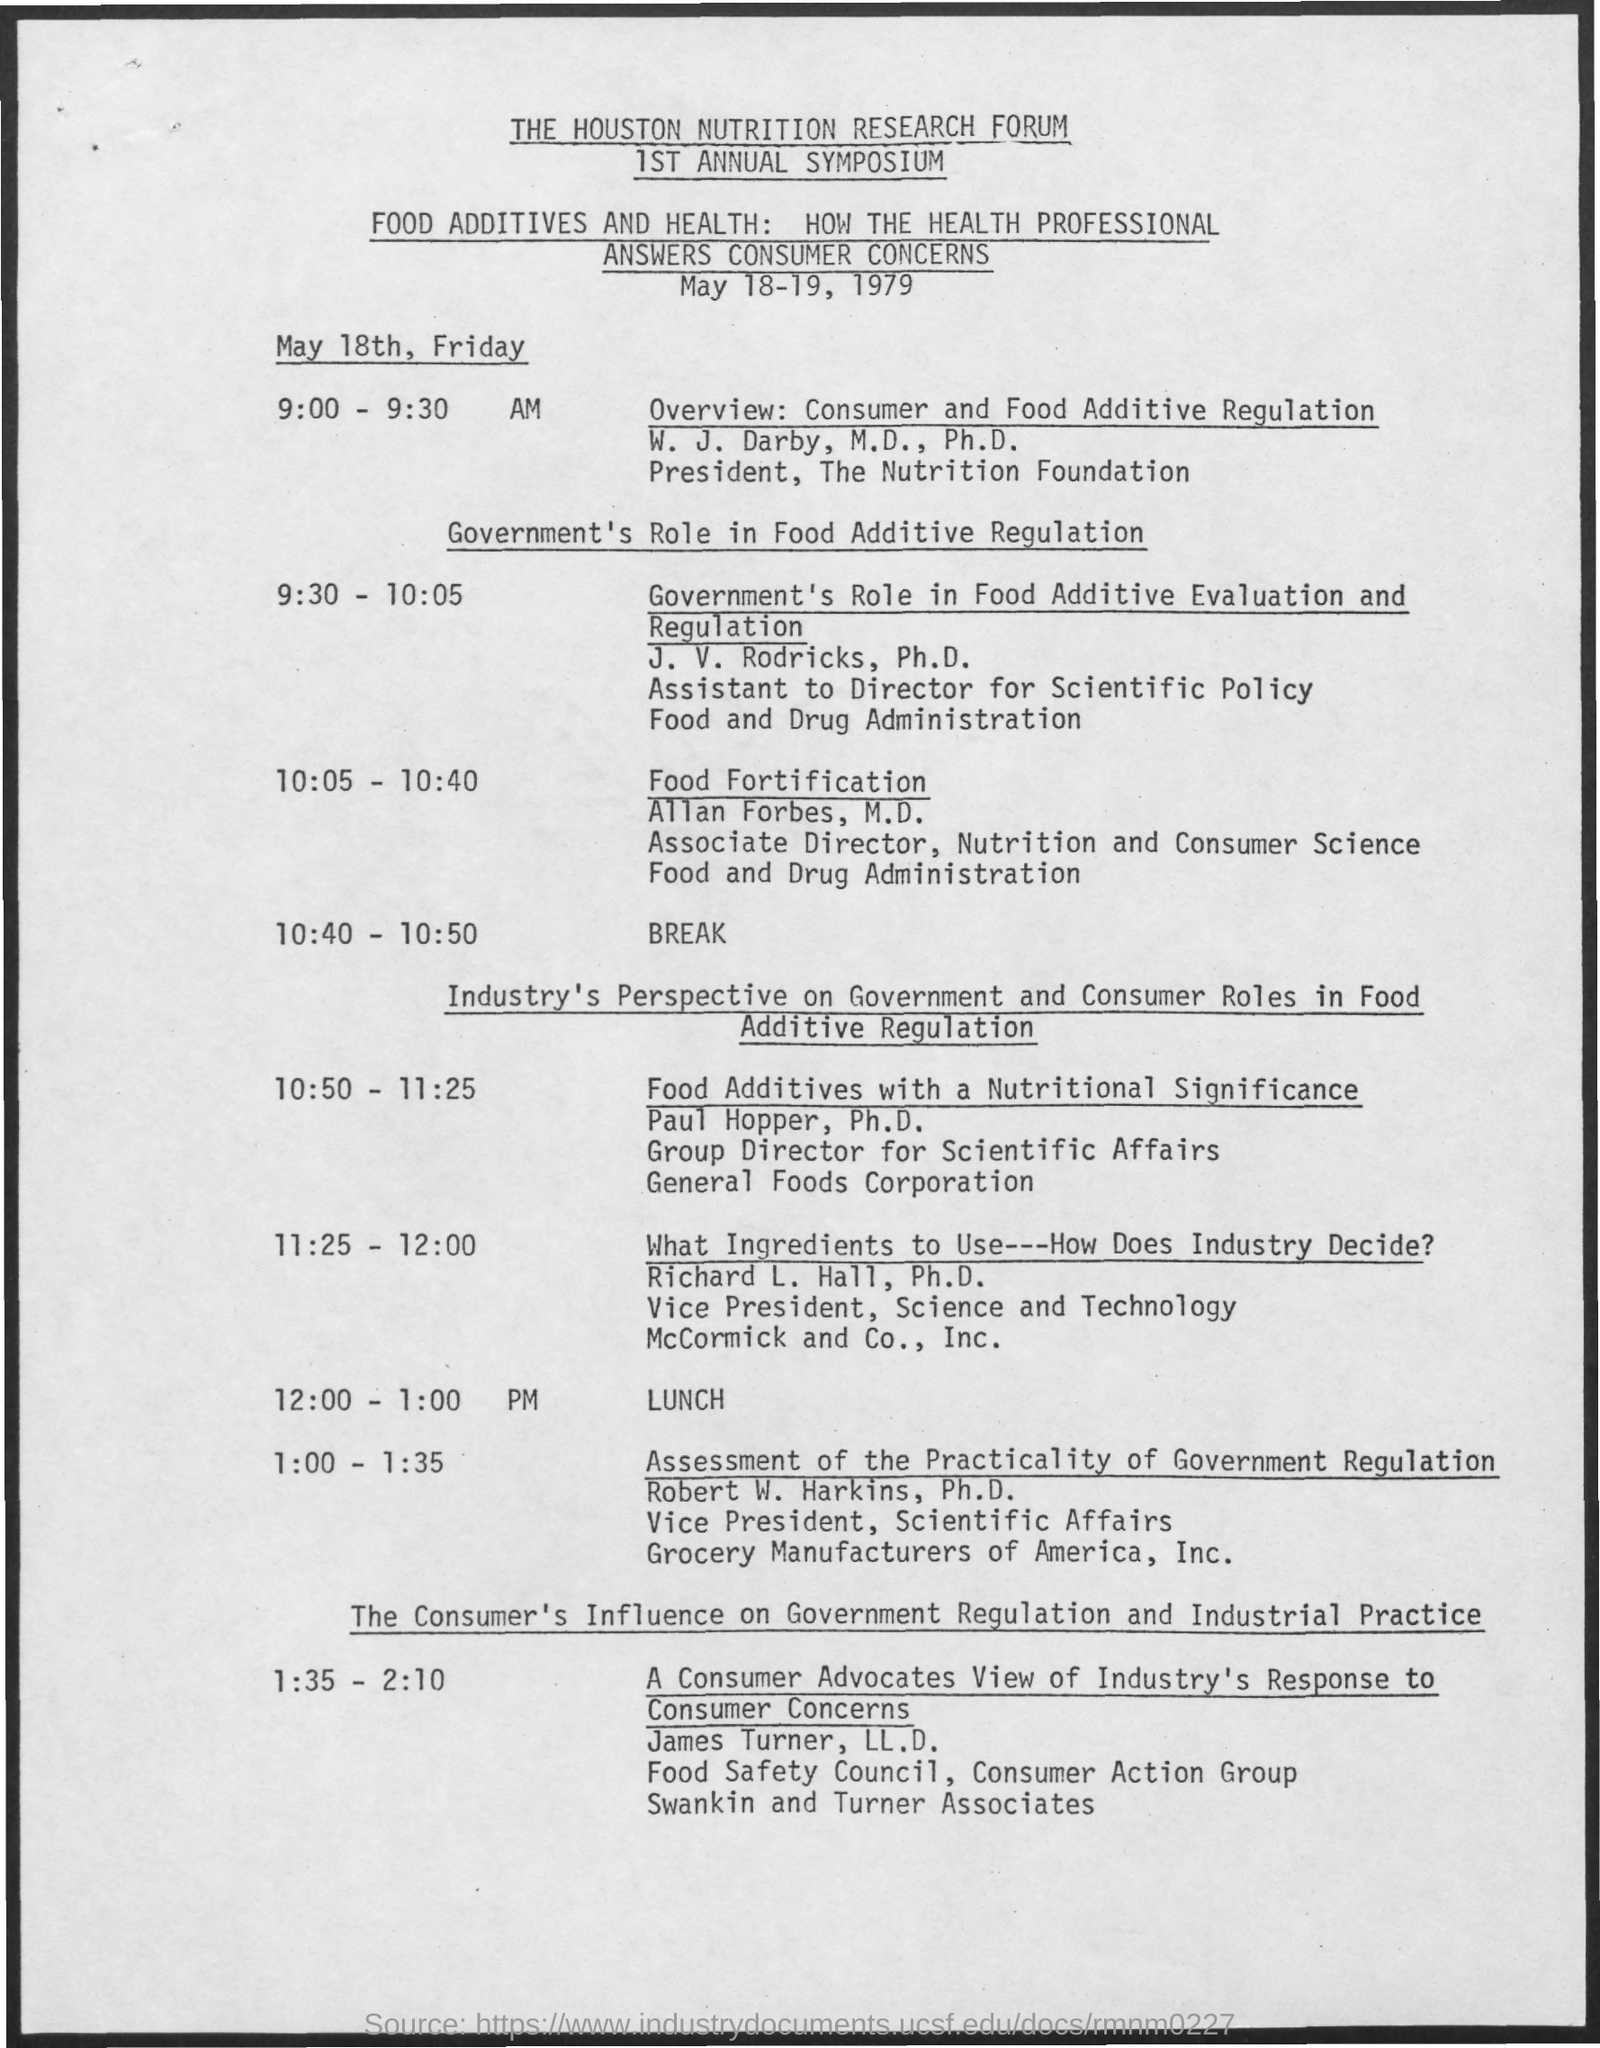Indicate a few pertinent items in this graphic. At 10:40-10:50, the schedule will be in effect. At the time of 12:00-1:00 pm, lunch is scheduled. The date mentioned in the given page is May 18-19, 1979. 